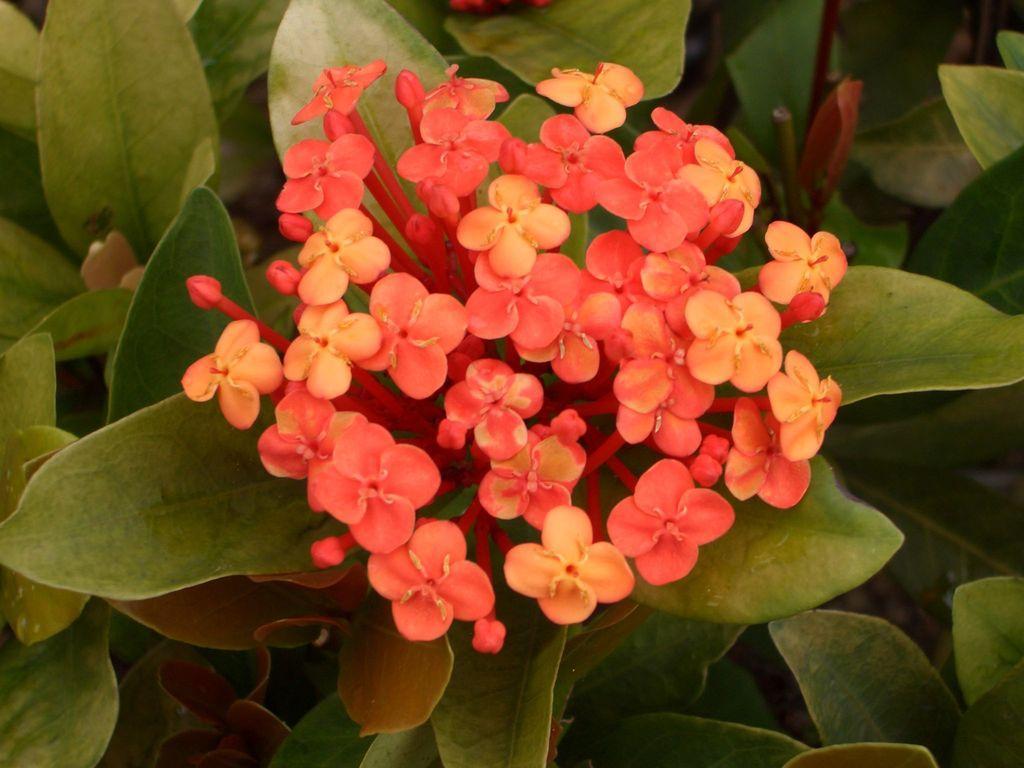How would you summarize this image in a sentence or two? In this image we can see there are flowers and leaves. 